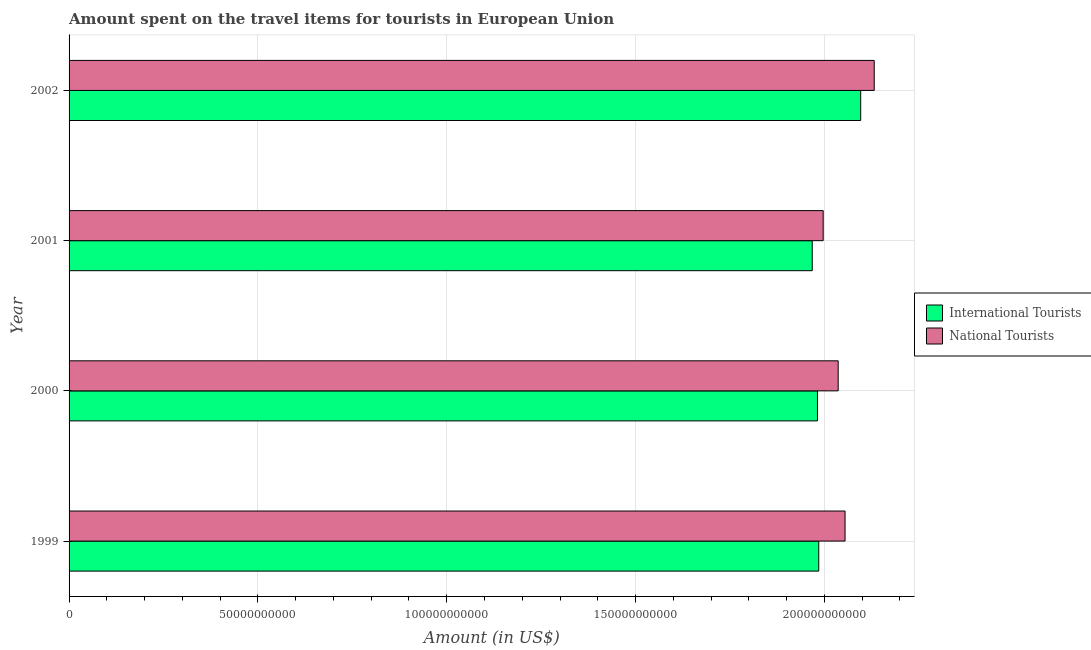How many groups of bars are there?
Ensure brevity in your answer.  4. Are the number of bars per tick equal to the number of legend labels?
Provide a succinct answer. Yes. How many bars are there on the 4th tick from the bottom?
Your answer should be compact. 2. What is the label of the 4th group of bars from the top?
Ensure brevity in your answer.  1999. In how many cases, is the number of bars for a given year not equal to the number of legend labels?
Give a very brief answer. 0. What is the amount spent on travel items of national tourists in 2000?
Offer a very short reply. 2.04e+11. Across all years, what is the maximum amount spent on travel items of national tourists?
Your response must be concise. 2.13e+11. Across all years, what is the minimum amount spent on travel items of national tourists?
Provide a short and direct response. 2.00e+11. What is the total amount spent on travel items of international tourists in the graph?
Your response must be concise. 8.03e+11. What is the difference between the amount spent on travel items of international tourists in 1999 and that in 2000?
Your answer should be compact. 3.41e+08. What is the difference between the amount spent on travel items of national tourists in 2002 and the amount spent on travel items of international tourists in 2001?
Give a very brief answer. 1.64e+1. What is the average amount spent on travel items of international tourists per year?
Your response must be concise. 2.01e+11. In the year 2001, what is the difference between the amount spent on travel items of national tourists and amount spent on travel items of international tourists?
Provide a short and direct response. 2.90e+09. What is the ratio of the amount spent on travel items of international tourists in 2001 to that in 2002?
Your response must be concise. 0.94. Is the amount spent on travel items of national tourists in 2000 less than that in 2001?
Ensure brevity in your answer.  No. Is the difference between the amount spent on travel items of international tourists in 2000 and 2002 greater than the difference between the amount spent on travel items of national tourists in 2000 and 2002?
Provide a short and direct response. No. What is the difference between the highest and the second highest amount spent on travel items of international tourists?
Offer a terse response. 1.11e+1. What is the difference between the highest and the lowest amount spent on travel items of national tourists?
Provide a succinct answer. 1.35e+1. What does the 1st bar from the top in 2001 represents?
Give a very brief answer. National Tourists. What does the 1st bar from the bottom in 2002 represents?
Offer a very short reply. International Tourists. How many bars are there?
Give a very brief answer. 8. Are all the bars in the graph horizontal?
Provide a succinct answer. Yes. What is the difference between two consecutive major ticks on the X-axis?
Your response must be concise. 5.00e+1. Are the values on the major ticks of X-axis written in scientific E-notation?
Ensure brevity in your answer.  No. Where does the legend appear in the graph?
Provide a short and direct response. Center right. What is the title of the graph?
Offer a terse response. Amount spent on the travel items for tourists in European Union. What is the Amount (in US$) of International Tourists in 1999?
Make the answer very short. 1.99e+11. What is the Amount (in US$) of National Tourists in 1999?
Give a very brief answer. 2.05e+11. What is the Amount (in US$) of International Tourists in 2000?
Provide a short and direct response. 1.98e+11. What is the Amount (in US$) of National Tourists in 2000?
Offer a terse response. 2.04e+11. What is the Amount (in US$) of International Tourists in 2001?
Make the answer very short. 1.97e+11. What is the Amount (in US$) in National Tourists in 2001?
Offer a terse response. 2.00e+11. What is the Amount (in US$) in International Tourists in 2002?
Offer a very short reply. 2.10e+11. What is the Amount (in US$) of National Tourists in 2002?
Offer a very short reply. 2.13e+11. Across all years, what is the maximum Amount (in US$) of International Tourists?
Your answer should be very brief. 2.10e+11. Across all years, what is the maximum Amount (in US$) in National Tourists?
Ensure brevity in your answer.  2.13e+11. Across all years, what is the minimum Amount (in US$) of International Tourists?
Offer a very short reply. 1.97e+11. Across all years, what is the minimum Amount (in US$) of National Tourists?
Offer a very short reply. 2.00e+11. What is the total Amount (in US$) in International Tourists in the graph?
Offer a terse response. 8.03e+11. What is the total Amount (in US$) of National Tourists in the graph?
Your answer should be very brief. 8.22e+11. What is the difference between the Amount (in US$) of International Tourists in 1999 and that in 2000?
Offer a terse response. 3.41e+08. What is the difference between the Amount (in US$) in National Tourists in 1999 and that in 2000?
Give a very brief answer. 1.82e+09. What is the difference between the Amount (in US$) of International Tourists in 1999 and that in 2001?
Your answer should be compact. 1.73e+09. What is the difference between the Amount (in US$) of National Tourists in 1999 and that in 2001?
Your answer should be compact. 5.79e+09. What is the difference between the Amount (in US$) in International Tourists in 1999 and that in 2002?
Your response must be concise. -1.11e+1. What is the difference between the Amount (in US$) of National Tourists in 1999 and that in 2002?
Your answer should be very brief. -7.72e+09. What is the difference between the Amount (in US$) of International Tourists in 2000 and that in 2001?
Offer a very short reply. 1.39e+09. What is the difference between the Amount (in US$) of National Tourists in 2000 and that in 2001?
Keep it short and to the point. 3.97e+09. What is the difference between the Amount (in US$) in International Tourists in 2000 and that in 2002?
Ensure brevity in your answer.  -1.14e+1. What is the difference between the Amount (in US$) of National Tourists in 2000 and that in 2002?
Your answer should be very brief. -9.54e+09. What is the difference between the Amount (in US$) in International Tourists in 2001 and that in 2002?
Offer a terse response. -1.28e+1. What is the difference between the Amount (in US$) in National Tourists in 2001 and that in 2002?
Give a very brief answer. -1.35e+1. What is the difference between the Amount (in US$) of International Tourists in 1999 and the Amount (in US$) of National Tourists in 2000?
Your response must be concise. -5.14e+09. What is the difference between the Amount (in US$) of International Tourists in 1999 and the Amount (in US$) of National Tourists in 2001?
Make the answer very short. -1.17e+09. What is the difference between the Amount (in US$) of International Tourists in 1999 and the Amount (in US$) of National Tourists in 2002?
Make the answer very short. -1.47e+1. What is the difference between the Amount (in US$) in International Tourists in 2000 and the Amount (in US$) in National Tourists in 2001?
Offer a very short reply. -1.51e+09. What is the difference between the Amount (in US$) in International Tourists in 2000 and the Amount (in US$) in National Tourists in 2002?
Make the answer very short. -1.50e+1. What is the difference between the Amount (in US$) of International Tourists in 2001 and the Amount (in US$) of National Tourists in 2002?
Give a very brief answer. -1.64e+1. What is the average Amount (in US$) in International Tourists per year?
Give a very brief answer. 2.01e+11. What is the average Amount (in US$) in National Tourists per year?
Give a very brief answer. 2.05e+11. In the year 1999, what is the difference between the Amount (in US$) in International Tourists and Amount (in US$) in National Tourists?
Offer a terse response. -6.96e+09. In the year 2000, what is the difference between the Amount (in US$) of International Tourists and Amount (in US$) of National Tourists?
Your answer should be compact. -5.48e+09. In the year 2001, what is the difference between the Amount (in US$) of International Tourists and Amount (in US$) of National Tourists?
Offer a very short reply. -2.90e+09. In the year 2002, what is the difference between the Amount (in US$) of International Tourists and Amount (in US$) of National Tourists?
Your response must be concise. -3.58e+09. What is the ratio of the Amount (in US$) in International Tourists in 1999 to that in 2000?
Provide a short and direct response. 1. What is the ratio of the Amount (in US$) in National Tourists in 1999 to that in 2000?
Provide a succinct answer. 1.01. What is the ratio of the Amount (in US$) in International Tourists in 1999 to that in 2001?
Provide a short and direct response. 1.01. What is the ratio of the Amount (in US$) in National Tourists in 1999 to that in 2001?
Provide a succinct answer. 1.03. What is the ratio of the Amount (in US$) of International Tourists in 1999 to that in 2002?
Make the answer very short. 0.95. What is the ratio of the Amount (in US$) of National Tourists in 1999 to that in 2002?
Offer a terse response. 0.96. What is the ratio of the Amount (in US$) of National Tourists in 2000 to that in 2001?
Ensure brevity in your answer.  1.02. What is the ratio of the Amount (in US$) of International Tourists in 2000 to that in 2002?
Your answer should be compact. 0.95. What is the ratio of the Amount (in US$) in National Tourists in 2000 to that in 2002?
Ensure brevity in your answer.  0.96. What is the ratio of the Amount (in US$) in International Tourists in 2001 to that in 2002?
Offer a terse response. 0.94. What is the ratio of the Amount (in US$) of National Tourists in 2001 to that in 2002?
Keep it short and to the point. 0.94. What is the difference between the highest and the second highest Amount (in US$) of International Tourists?
Your response must be concise. 1.11e+1. What is the difference between the highest and the second highest Amount (in US$) of National Tourists?
Provide a succinct answer. 7.72e+09. What is the difference between the highest and the lowest Amount (in US$) in International Tourists?
Make the answer very short. 1.28e+1. What is the difference between the highest and the lowest Amount (in US$) in National Tourists?
Ensure brevity in your answer.  1.35e+1. 